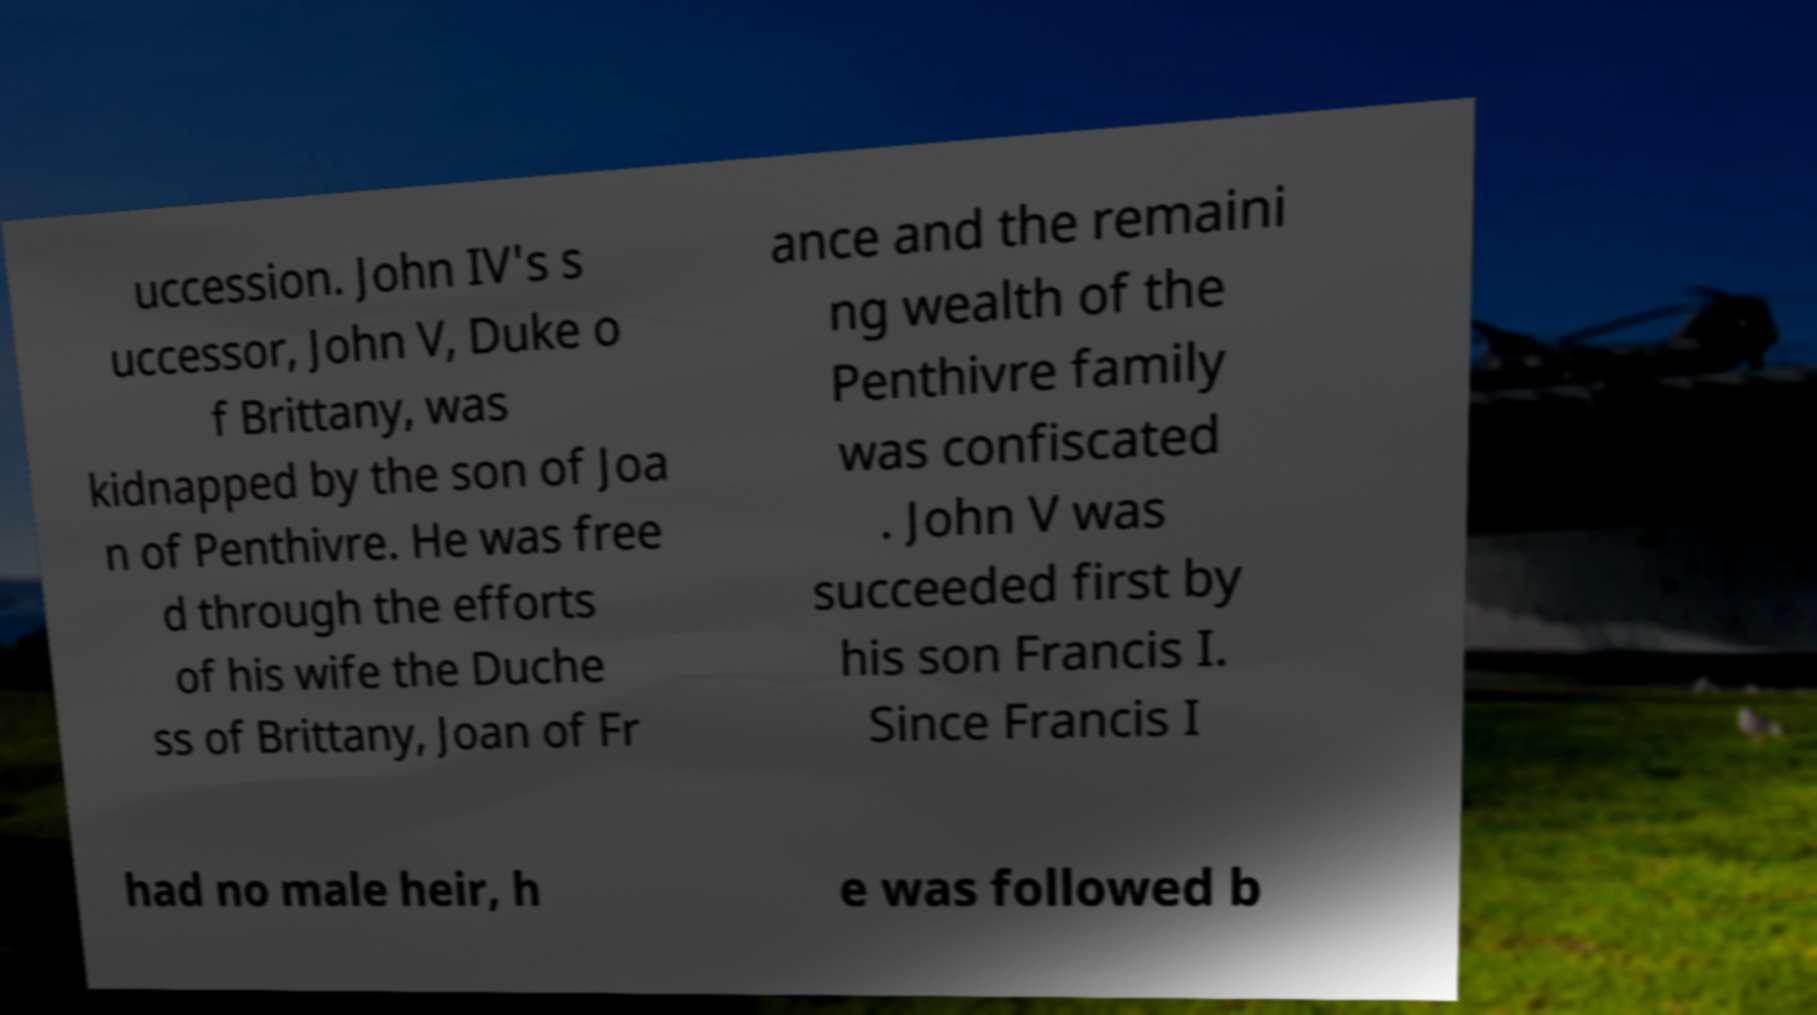Could you assist in decoding the text presented in this image and type it out clearly? uccession. John IV's s uccessor, John V, Duke o f Brittany, was kidnapped by the son of Joa n of Penthivre. He was free d through the efforts of his wife the Duche ss of Brittany, Joan of Fr ance and the remaini ng wealth of the Penthivre family was confiscated . John V was succeeded first by his son Francis I. Since Francis I had no male heir, h e was followed b 